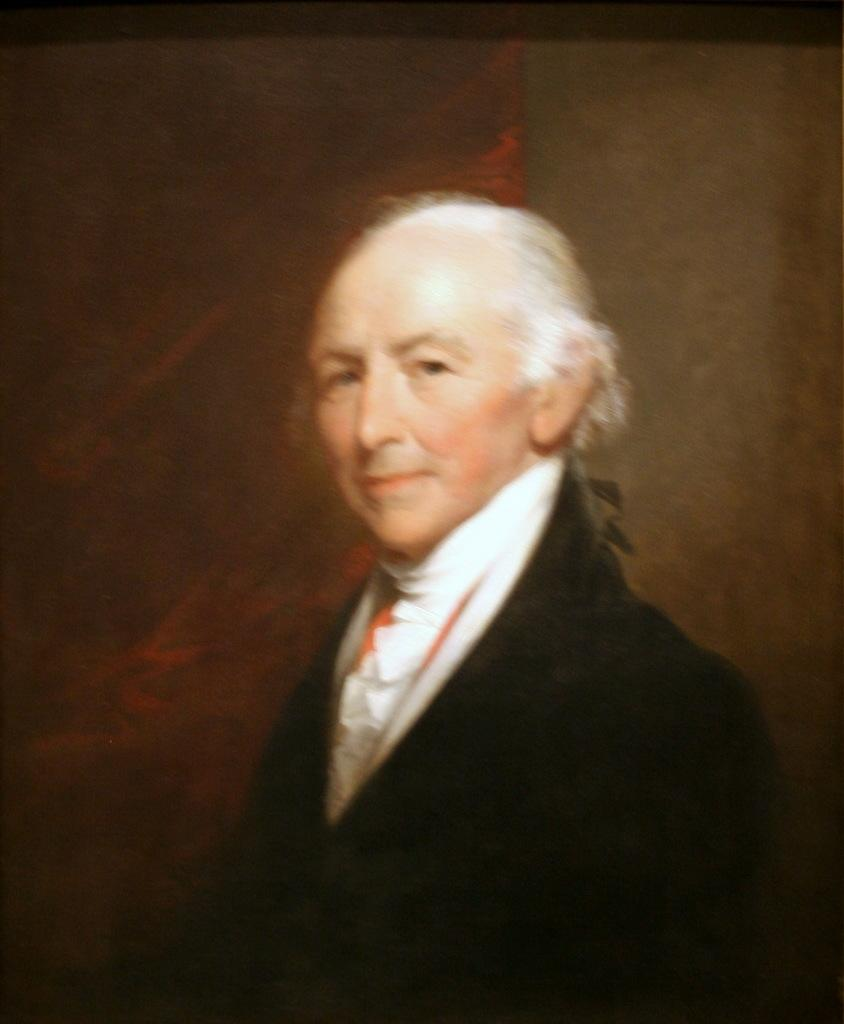What is the main subject of the image? There is a portrait in the image. Who is depicted in the portrait? There is a man in the portrait. What is the man wearing in the portrait? The man is wearing a formal suit. How many arms does the man have in the portrait? The number of arms cannot be determined from the image, as it only shows the man's torso and head. 